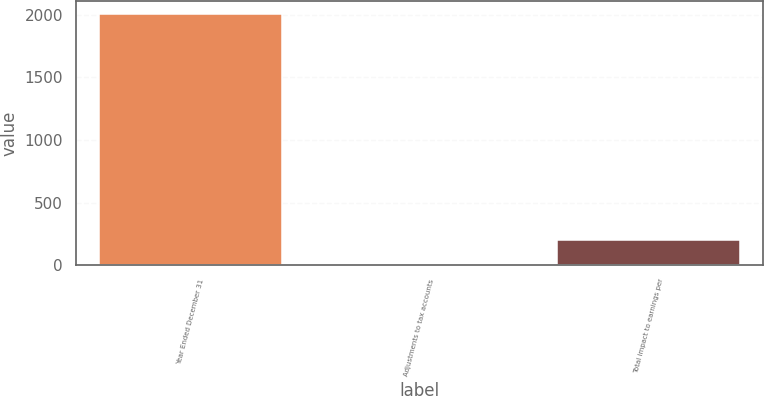Convert chart. <chart><loc_0><loc_0><loc_500><loc_500><bar_chart><fcel>Year Ended December 31<fcel>Adjustments to tax accounts<fcel>Total impact to earnings per<nl><fcel>2008<fcel>0.02<fcel>200.82<nl></chart> 